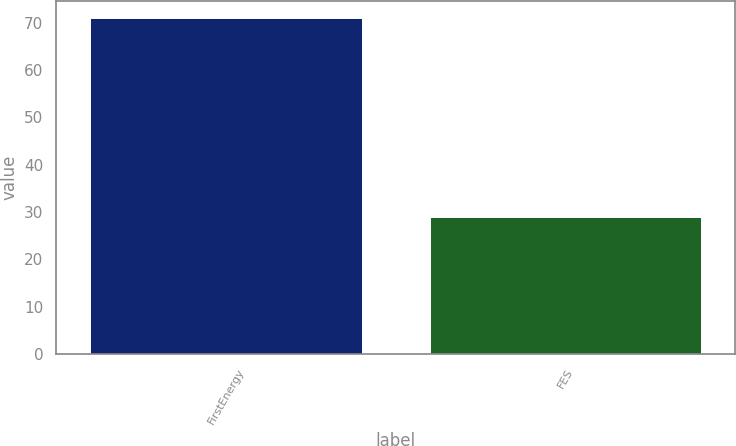Convert chart. <chart><loc_0><loc_0><loc_500><loc_500><bar_chart><fcel>FirstEnergy<fcel>FES<nl><fcel>71<fcel>29<nl></chart> 